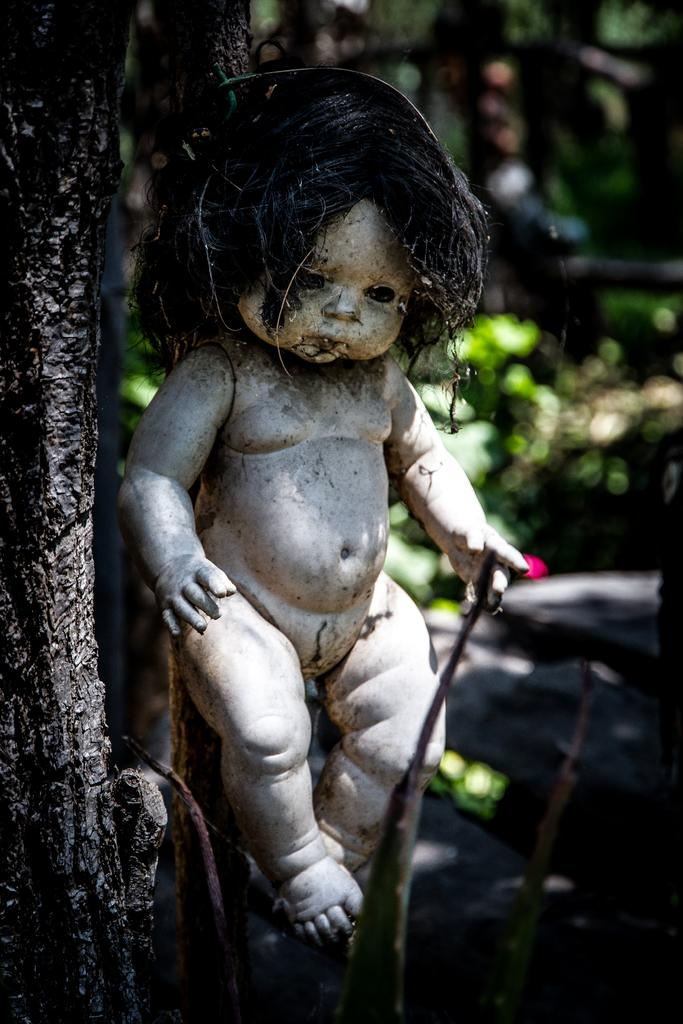What is the main subject in the front of the image? There is a baby doll in the front of the image. What can be seen on the left side of the image? There is a tree on the left side of the image. What type of vegetation is visible in the background of the image? There are plants visible in the background of the image. How would you describe the appearance of the background in the image? The background of the image appears blurry. What type of produce is hanging from the tree in the image? There is no produce visible on the tree in the image. Can you see a cat playing with the baby doll in the image? There is no cat present in the image; it only features a baby doll and a tree. 